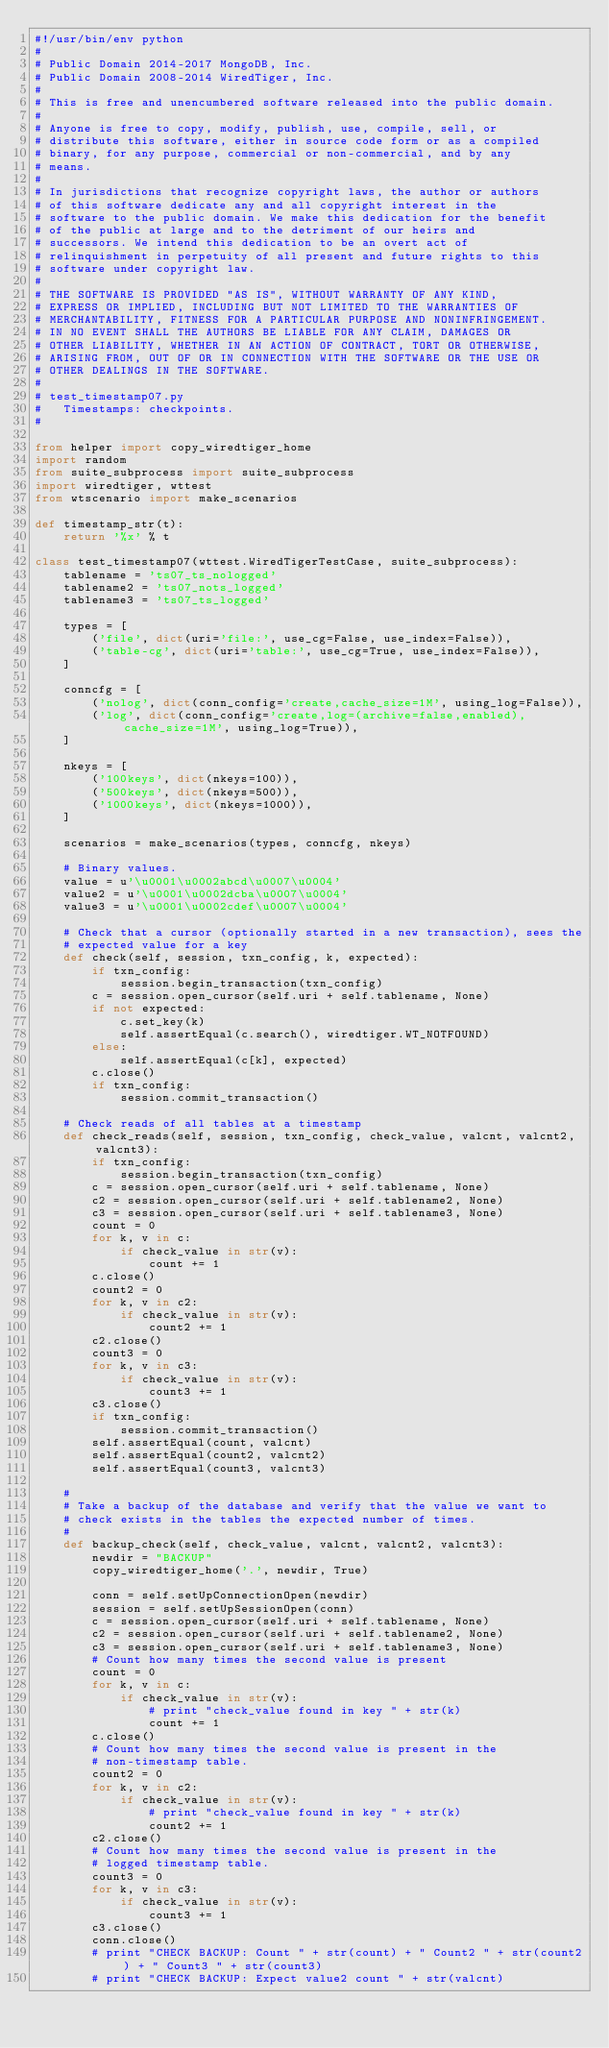Convert code to text. <code><loc_0><loc_0><loc_500><loc_500><_Python_>#!/usr/bin/env python
#
# Public Domain 2014-2017 MongoDB, Inc.
# Public Domain 2008-2014 WiredTiger, Inc.
#
# This is free and unencumbered software released into the public domain.
#
# Anyone is free to copy, modify, publish, use, compile, sell, or
# distribute this software, either in source code form or as a compiled
# binary, for any purpose, commercial or non-commercial, and by any
# means.
#
# In jurisdictions that recognize copyright laws, the author or authors
# of this software dedicate any and all copyright interest in the
# software to the public domain. We make this dedication for the benefit
# of the public at large and to the detriment of our heirs and
# successors. We intend this dedication to be an overt act of
# relinquishment in perpetuity of all present and future rights to this
# software under copyright law.
#
# THE SOFTWARE IS PROVIDED "AS IS", WITHOUT WARRANTY OF ANY KIND,
# EXPRESS OR IMPLIED, INCLUDING BUT NOT LIMITED TO THE WARRANTIES OF
# MERCHANTABILITY, FITNESS FOR A PARTICULAR PURPOSE AND NONINFRINGEMENT.
# IN NO EVENT SHALL THE AUTHORS BE LIABLE FOR ANY CLAIM, DAMAGES OR
# OTHER LIABILITY, WHETHER IN AN ACTION OF CONTRACT, TORT OR OTHERWISE,
# ARISING FROM, OUT OF OR IN CONNECTION WITH THE SOFTWARE OR THE USE OR
# OTHER DEALINGS IN THE SOFTWARE.
#
# test_timestamp07.py
#   Timestamps: checkpoints.
#

from helper import copy_wiredtiger_home
import random
from suite_subprocess import suite_subprocess
import wiredtiger, wttest
from wtscenario import make_scenarios

def timestamp_str(t):
    return '%x' % t

class test_timestamp07(wttest.WiredTigerTestCase, suite_subprocess):
    tablename = 'ts07_ts_nologged'
    tablename2 = 'ts07_nots_logged'
    tablename3 = 'ts07_ts_logged'

    types = [
        ('file', dict(uri='file:', use_cg=False, use_index=False)),
        ('table-cg', dict(uri='table:', use_cg=True, use_index=False)),
    ]

    conncfg = [
        ('nolog', dict(conn_config='create,cache_size=1M', using_log=False)),
        ('log', dict(conn_config='create,log=(archive=false,enabled),cache_size=1M', using_log=True)),
    ]

    nkeys = [
        ('100keys', dict(nkeys=100)),
        ('500keys', dict(nkeys=500)),
        ('1000keys', dict(nkeys=1000)),
    ]

    scenarios = make_scenarios(types, conncfg, nkeys)

    # Binary values.
    value = u'\u0001\u0002abcd\u0007\u0004'
    value2 = u'\u0001\u0002dcba\u0007\u0004'
    value3 = u'\u0001\u0002cdef\u0007\u0004'

    # Check that a cursor (optionally started in a new transaction), sees the
    # expected value for a key
    def check(self, session, txn_config, k, expected):
        if txn_config:
            session.begin_transaction(txn_config)
        c = session.open_cursor(self.uri + self.tablename, None)
        if not expected:
            c.set_key(k)
            self.assertEqual(c.search(), wiredtiger.WT_NOTFOUND)
        else:
            self.assertEqual(c[k], expected)
        c.close()
        if txn_config:
            session.commit_transaction()

    # Check reads of all tables at a timestamp
    def check_reads(self, session, txn_config, check_value, valcnt, valcnt2, valcnt3):
        if txn_config:
            session.begin_transaction(txn_config)
        c = session.open_cursor(self.uri + self.tablename, None)
        c2 = session.open_cursor(self.uri + self.tablename2, None)
        c3 = session.open_cursor(self.uri + self.tablename3, None)
        count = 0
        for k, v in c:
            if check_value in str(v):
                count += 1
        c.close()
        count2 = 0
        for k, v in c2:
            if check_value in str(v):
                count2 += 1
        c2.close()
        count3 = 0
        for k, v in c3:
            if check_value in str(v):
                count3 += 1
        c3.close()
        if txn_config:
            session.commit_transaction()
        self.assertEqual(count, valcnt)
        self.assertEqual(count2, valcnt2)
        self.assertEqual(count3, valcnt3)

    #
    # Take a backup of the database and verify that the value we want to
    # check exists in the tables the expected number of times.
    #
    def backup_check(self, check_value, valcnt, valcnt2, valcnt3):
        newdir = "BACKUP"
        copy_wiredtiger_home('.', newdir, True)

        conn = self.setUpConnectionOpen(newdir)
        session = self.setUpSessionOpen(conn)
        c = session.open_cursor(self.uri + self.tablename, None)
        c2 = session.open_cursor(self.uri + self.tablename2, None)
        c3 = session.open_cursor(self.uri + self.tablename3, None)
        # Count how many times the second value is present
        count = 0
        for k, v in c:
            if check_value in str(v):
                # print "check_value found in key " + str(k)
                count += 1
        c.close()
        # Count how many times the second value is present in the
        # non-timestamp table.
        count2 = 0
        for k, v in c2:
            if check_value in str(v):
                # print "check_value found in key " + str(k)
                count2 += 1
        c2.close()
        # Count how many times the second value is present in the
        # logged timestamp table.
        count3 = 0
        for k, v in c3:
            if check_value in str(v):
                count3 += 1
        c3.close()
        conn.close()
        # print "CHECK BACKUP: Count " + str(count) + " Count2 " + str(count2) + " Count3 " + str(count3)
        # print "CHECK BACKUP: Expect value2 count " + str(valcnt)</code> 